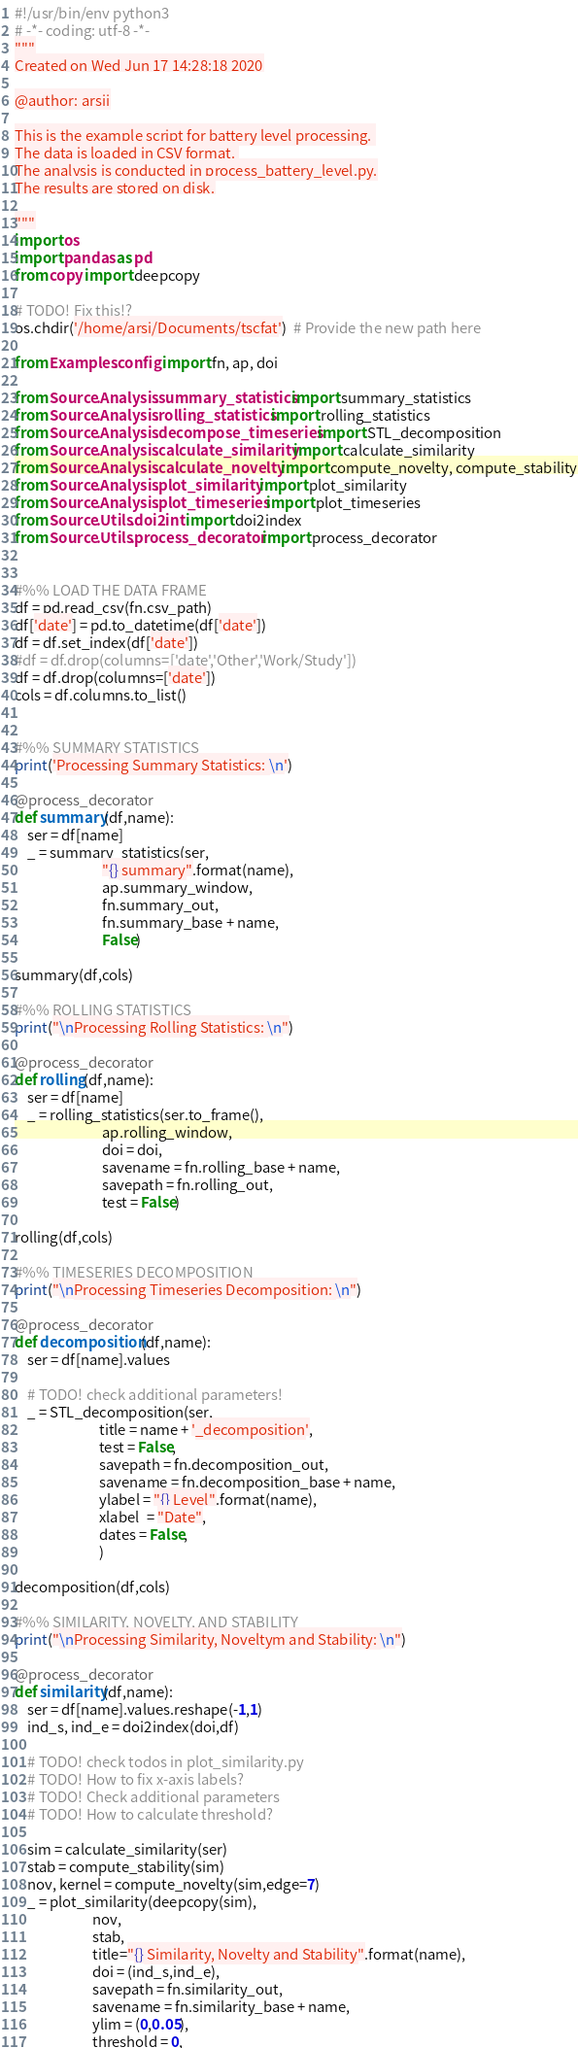<code> <loc_0><loc_0><loc_500><loc_500><_Python_>#!/usr/bin/env python3
# -*- coding: utf-8 -*-
"""
Created on Wed Jun 17 14:28:18 2020

@author: arsii

This is the example script for battery level processing. 
The data is loaded in CSV format. 
The analysis is conducted in process_battery_level.py.
The results are stored on disk.

"""
import os
import pandas as pd
from copy import deepcopy

# TODO! Fix this!?
os.chdir('/home/arsi/Documents/tscfat')  # Provide the new path here

from Examples.config import fn, ap, doi

from Source.Analysis.summary_statistics import summary_statistics
from Source.Analysis.rolling_statistics import rolling_statistics
from Source.Analysis.decompose_timeseries import STL_decomposition
from Source.Analysis.calculate_similarity import calculate_similarity
from Source.Analysis.calculate_novelty import compute_novelty, compute_stability
from Source.Analysis.plot_similarity import plot_similarity
from Source.Analysis.plot_timeseries import plot_timeseries
from Source.Utils.doi2int import doi2index
from Source.Utils.process_decorator import process_decorator


#%% LOAD THE DATA FRAME
df = pd.read_csv(fn.csv_path)
df['date'] = pd.to_datetime(df['date'])
df = df.set_index(df['date'])
#df = df.drop(columns=['date','Other','Work/Study'])
df = df.drop(columns=['date'])
cols = df.columns.to_list()


#%% SUMMARY STATISTICS
print('Processing Summary Statistics: \n')

@process_decorator
def summary(df,name):
    ser = df[name] 
    _ = summary_statistics(ser,
                           "{} summary".format(name),
                           ap.summary_window,
                           fn.summary_out,
                           fn.summary_base + name,
                           False)

summary(df,cols)

#%% ROLLING STATISTICS 
print("\nProcessing Rolling Statistics: \n")

@process_decorator
def rolling(df,name):
    ser = df[name] 
    _ = rolling_statistics(ser.to_frame(),
                           ap.rolling_window,
                           doi = doi,
                           savename = fn.rolling_base + name,
                           savepath = fn.rolling_out,
                           test = False)

rolling(df,cols)

#%% TIMESERIES DECOMPOSITION
print("\nProcessing Timeseries Decomposition: \n")

@process_decorator
def decomposition(df,name):
    ser = df[name].values
    
    # TODO! check additional parameters!
    _ = STL_decomposition(ser,
                          title = name + '_decomposition',
                          test = False,
                          savepath = fn.decomposition_out,
                          savename = fn.decomposition_base + name,
                          ylabel = "{} Level".format(name),
                          xlabel  = "Date",
                          dates = False,
                          )

decomposition(df,cols)

#%% SIMILARITY, NOVELTY, AND STABILITY
print("\nProcessing Similarity, Noveltym and Stability: \n")

@process_decorator
def similarity(df,name):
    ser = df[name].values.reshape(-1,1)
    ind_s, ind_e = doi2index(doi,df)
    
    # TODO! check todos in plot_similarity.py
    # TODO! How to fix x-axis labels?
    # TODO! Check additional parameters
    # TODO! How to calculate threshold?
    
    sim = calculate_similarity(ser)
    stab = compute_stability(sim)
    nov, kernel = compute_novelty(sim,edge=7)
    _ = plot_similarity(deepcopy(sim),
                        nov,
                        stab,
                        title="{} Similarity, Novelty and Stability".format(name),
                        doi = (ind_s,ind_e),
                        savepath = fn.similarity_out, 
                        savename = fn.similarity_base + name,
                        ylim = (0,0.05),
                        threshold = 0,</code> 